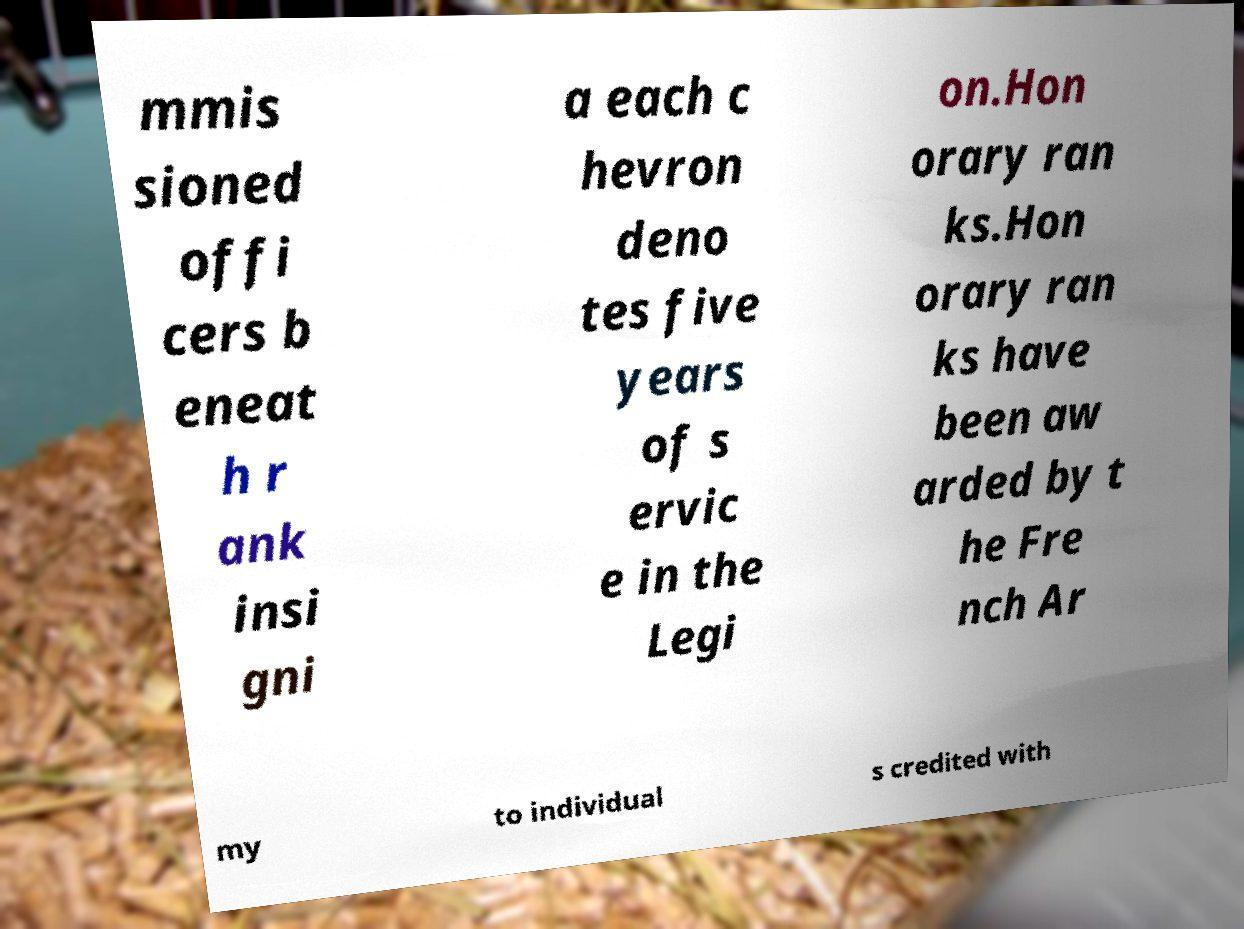Could you assist in decoding the text presented in this image and type it out clearly? mmis sioned offi cers b eneat h r ank insi gni a each c hevron deno tes five years of s ervic e in the Legi on.Hon orary ran ks.Hon orary ran ks have been aw arded by t he Fre nch Ar my to individual s credited with 